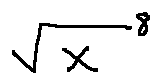Convert formula to latex. <formula><loc_0><loc_0><loc_500><loc_500>\sqrt { X } ^ { 8 }</formula> 